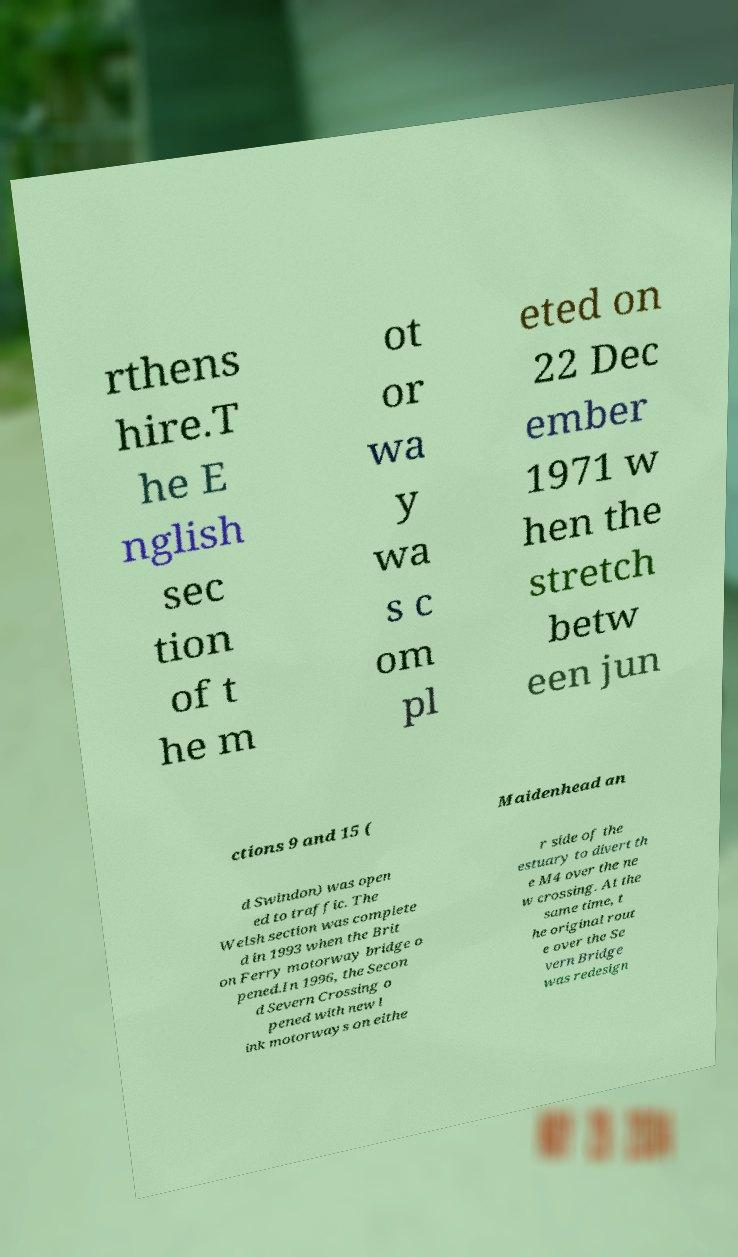What messages or text are displayed in this image? I need them in a readable, typed format. rthens hire.T he E nglish sec tion of t he m ot or wa y wa s c om pl eted on 22 Dec ember 1971 w hen the stretch betw een jun ctions 9 and 15 ( Maidenhead an d Swindon) was open ed to traffic. The Welsh section was complete d in 1993 when the Brit on Ferry motorway bridge o pened.In 1996, the Secon d Severn Crossing o pened with new l ink motorways on eithe r side of the estuary to divert th e M4 over the ne w crossing. At the same time, t he original rout e over the Se vern Bridge was redesign 